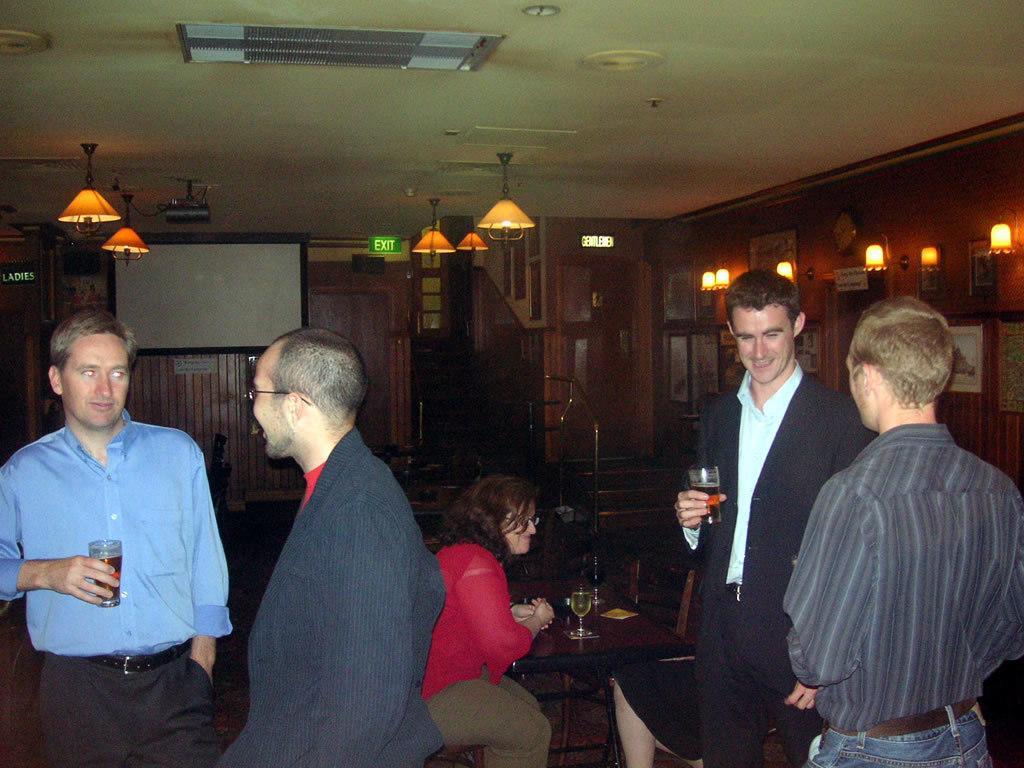Could you give a brief overview of what you see in this image? In the picture I can see a person wearing the blue color shirt is holding a glass with a drink in it and a person wearing a black blazer and spectacles are standing on a left side of the image. On the right side of the image we can see a person wearing a shirt and a person wearing blazer is holding a glass with a drink in it are standing. Here we can see a woman wearing a red color dress and other women are sitting on the chairs near the table where glasses with drinks in it are placed. In the background, we can see the LED projector screen, exit board, ceiling lights, projector, steps, photo frames on the wall and a board on the left side of the image. 